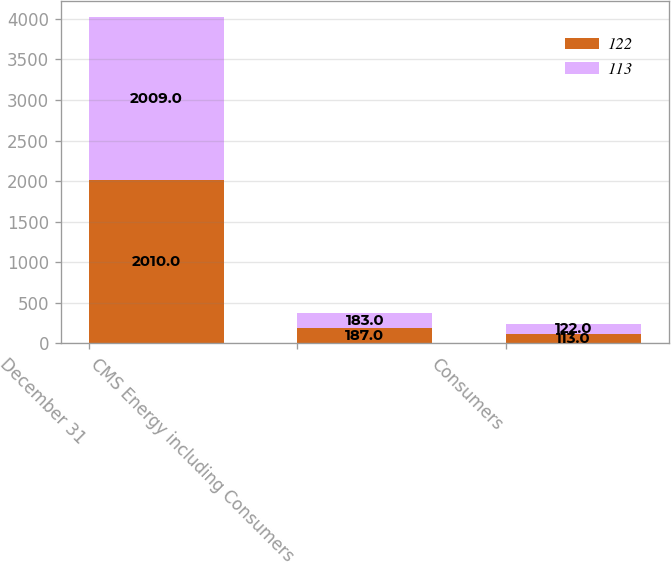<chart> <loc_0><loc_0><loc_500><loc_500><stacked_bar_chart><ecel><fcel>December 31<fcel>CMS Energy including Consumers<fcel>Consumers<nl><fcel>122<fcel>2010<fcel>187<fcel>113<nl><fcel>113<fcel>2009<fcel>183<fcel>122<nl></chart> 